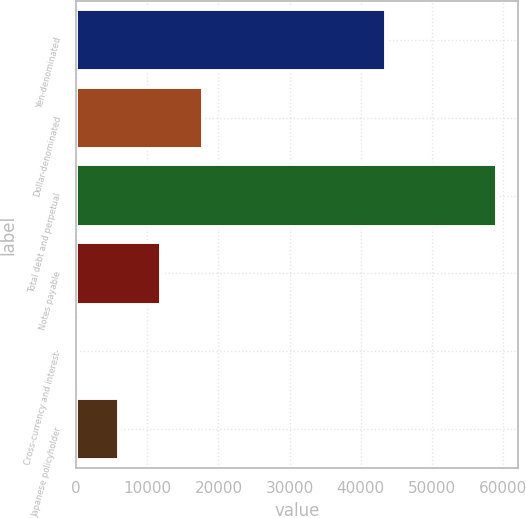<chart> <loc_0><loc_0><loc_500><loc_500><bar_chart><fcel>Yen-denominated<fcel>Dollar-denominated<fcel>Total debt and perpetual<fcel>Notes payable<fcel>Cross-currency and interest-<fcel>Japanese policyholder<nl><fcel>43556<fcel>17844.7<fcel>59130<fcel>11946.8<fcel>151<fcel>6048.9<nl></chart> 